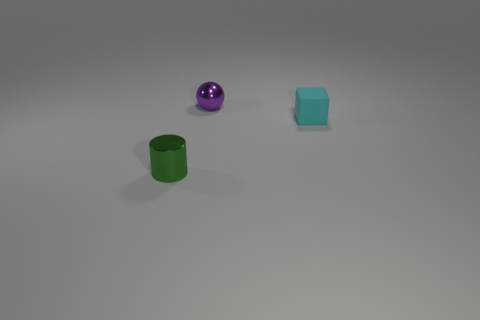The small object that is made of the same material as the ball is what color? The small object resembling a cube shares the same glossy and reflective surface material as the purple ball, indicating they are likely made from similar materials. It is a teal color. 